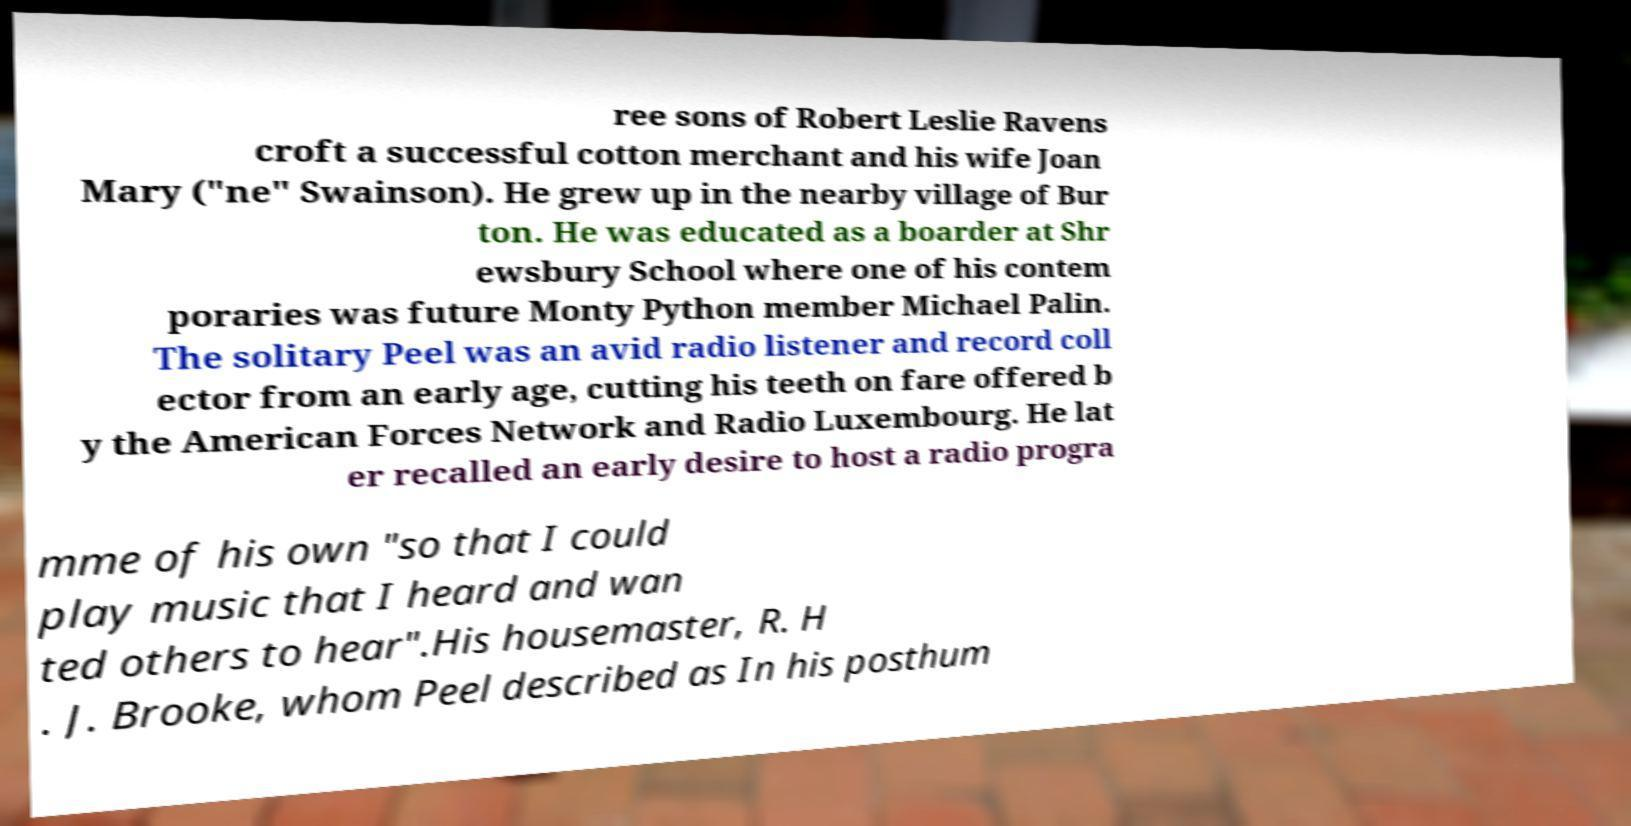There's text embedded in this image that I need extracted. Can you transcribe it verbatim? ree sons of Robert Leslie Ravens croft a successful cotton merchant and his wife Joan Mary ("ne" Swainson). He grew up in the nearby village of Bur ton. He was educated as a boarder at Shr ewsbury School where one of his contem poraries was future Monty Python member Michael Palin. The solitary Peel was an avid radio listener and record coll ector from an early age, cutting his teeth on fare offered b y the American Forces Network and Radio Luxembourg. He lat er recalled an early desire to host a radio progra mme of his own "so that I could play music that I heard and wan ted others to hear".His housemaster, R. H . J. Brooke, whom Peel described as In his posthum 